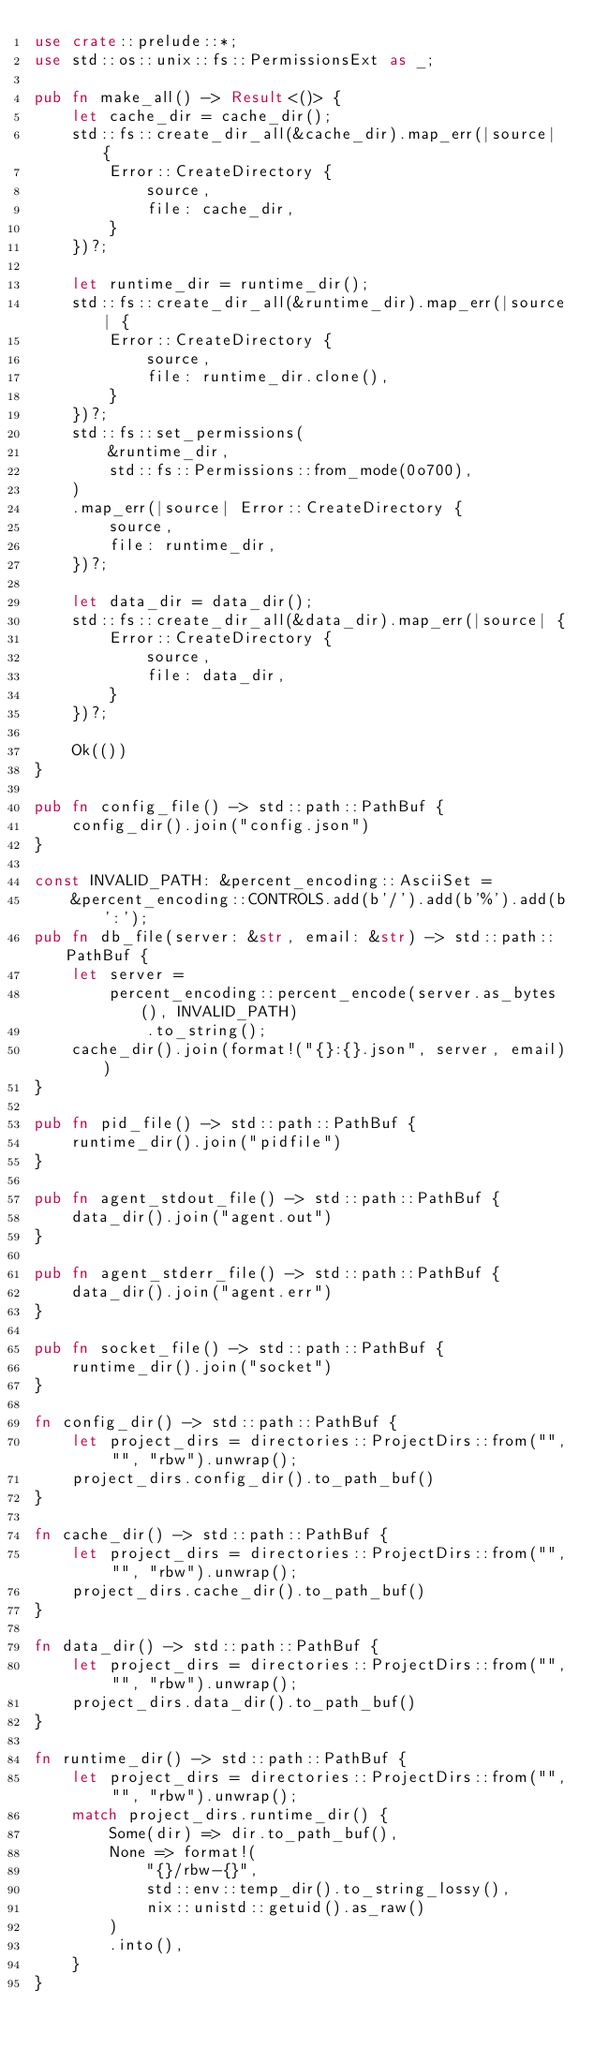Convert code to text. <code><loc_0><loc_0><loc_500><loc_500><_Rust_>use crate::prelude::*;
use std::os::unix::fs::PermissionsExt as _;

pub fn make_all() -> Result<()> {
    let cache_dir = cache_dir();
    std::fs::create_dir_all(&cache_dir).map_err(|source| {
        Error::CreateDirectory {
            source,
            file: cache_dir,
        }
    })?;

    let runtime_dir = runtime_dir();
    std::fs::create_dir_all(&runtime_dir).map_err(|source| {
        Error::CreateDirectory {
            source,
            file: runtime_dir.clone(),
        }
    })?;
    std::fs::set_permissions(
        &runtime_dir,
        std::fs::Permissions::from_mode(0o700),
    )
    .map_err(|source| Error::CreateDirectory {
        source,
        file: runtime_dir,
    })?;

    let data_dir = data_dir();
    std::fs::create_dir_all(&data_dir).map_err(|source| {
        Error::CreateDirectory {
            source,
            file: data_dir,
        }
    })?;

    Ok(())
}

pub fn config_file() -> std::path::PathBuf {
    config_dir().join("config.json")
}

const INVALID_PATH: &percent_encoding::AsciiSet =
    &percent_encoding::CONTROLS.add(b'/').add(b'%').add(b':');
pub fn db_file(server: &str, email: &str) -> std::path::PathBuf {
    let server =
        percent_encoding::percent_encode(server.as_bytes(), INVALID_PATH)
            .to_string();
    cache_dir().join(format!("{}:{}.json", server, email))
}

pub fn pid_file() -> std::path::PathBuf {
    runtime_dir().join("pidfile")
}

pub fn agent_stdout_file() -> std::path::PathBuf {
    data_dir().join("agent.out")
}

pub fn agent_stderr_file() -> std::path::PathBuf {
    data_dir().join("agent.err")
}

pub fn socket_file() -> std::path::PathBuf {
    runtime_dir().join("socket")
}

fn config_dir() -> std::path::PathBuf {
    let project_dirs = directories::ProjectDirs::from("", "", "rbw").unwrap();
    project_dirs.config_dir().to_path_buf()
}

fn cache_dir() -> std::path::PathBuf {
    let project_dirs = directories::ProjectDirs::from("", "", "rbw").unwrap();
    project_dirs.cache_dir().to_path_buf()
}

fn data_dir() -> std::path::PathBuf {
    let project_dirs = directories::ProjectDirs::from("", "", "rbw").unwrap();
    project_dirs.data_dir().to_path_buf()
}

fn runtime_dir() -> std::path::PathBuf {
    let project_dirs = directories::ProjectDirs::from("", "", "rbw").unwrap();
    match project_dirs.runtime_dir() {
        Some(dir) => dir.to_path_buf(),
        None => format!(
            "{}/rbw-{}",
            std::env::temp_dir().to_string_lossy(),
            nix::unistd::getuid().as_raw()
        )
        .into(),
    }
}
</code> 